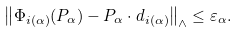<formula> <loc_0><loc_0><loc_500><loc_500>\left \| \Phi _ { i ( \alpha ) } ( P _ { \alpha } ) - P _ { \alpha } \cdot d _ { i ( \alpha ) } \right \| _ { \wedge } \leq \varepsilon _ { \alpha } .</formula> 